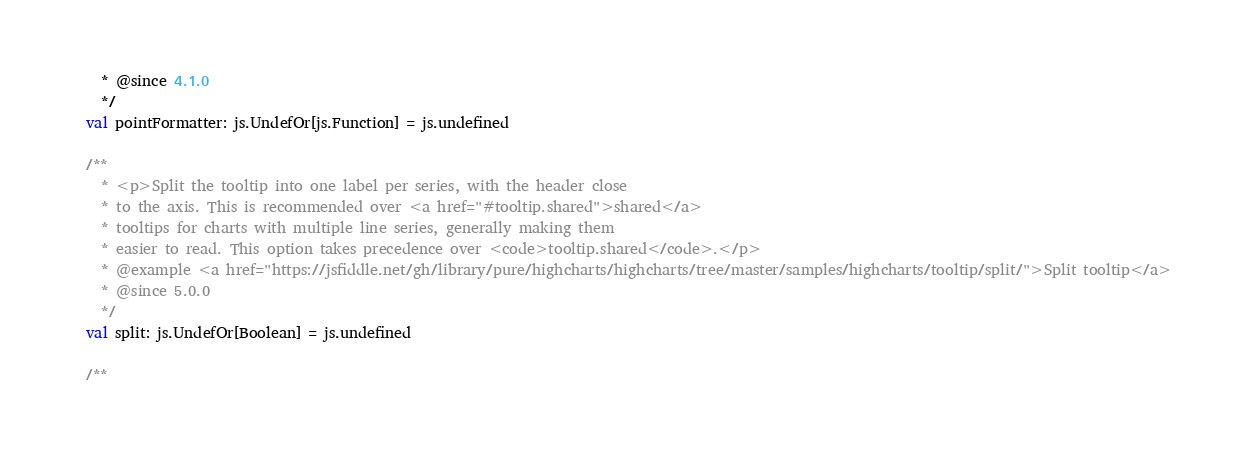<code> <loc_0><loc_0><loc_500><loc_500><_Scala_>    * @since 4.1.0
    */
  val pointFormatter: js.UndefOr[js.Function] = js.undefined

  /**
    * <p>Split the tooltip into one label per series, with the header close
    * to the axis. This is recommended over <a href="#tooltip.shared">shared</a>
    * tooltips for charts with multiple line series, generally making them
    * easier to read. This option takes precedence over <code>tooltip.shared</code>.</p>
    * @example <a href="https://jsfiddle.net/gh/library/pure/highcharts/highcharts/tree/master/samples/highcharts/tooltip/split/">Split tooltip</a>
    * @since 5.0.0
    */
  val split: js.UndefOr[Boolean] = js.undefined

  /**</code> 